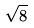<formula> <loc_0><loc_0><loc_500><loc_500>\sqrt { 8 }</formula> 